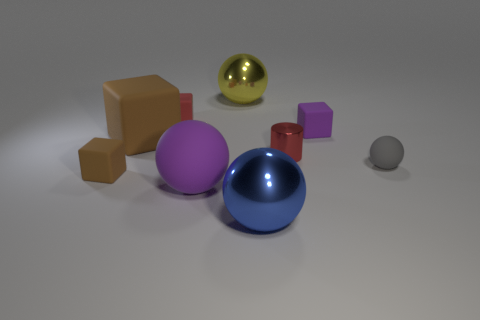What is the material of the small thing that is both left of the large blue metallic thing and behind the tiny red metallic thing?
Make the answer very short. Rubber. Is there anything else that is the same size as the red metallic cylinder?
Make the answer very short. Yes. Does the small matte sphere have the same color as the small metallic cylinder?
Make the answer very short. No. The small thing that is the same color as the small cylinder is what shape?
Offer a very short reply. Cube. What number of large brown objects have the same shape as the big blue metal object?
Keep it short and to the point. 0. The red block that is the same material as the purple cube is what size?
Make the answer very short. Small. Do the gray thing and the cylinder have the same size?
Your response must be concise. Yes. Is there a small rubber thing?
Offer a very short reply. Yes. What size is the matte thing that is the same color as the metal cylinder?
Make the answer very short. Small. There is a rubber thing that is on the right side of the small cube that is to the right of the matte cube behind the purple matte cube; what is its size?
Provide a succinct answer. Small. 